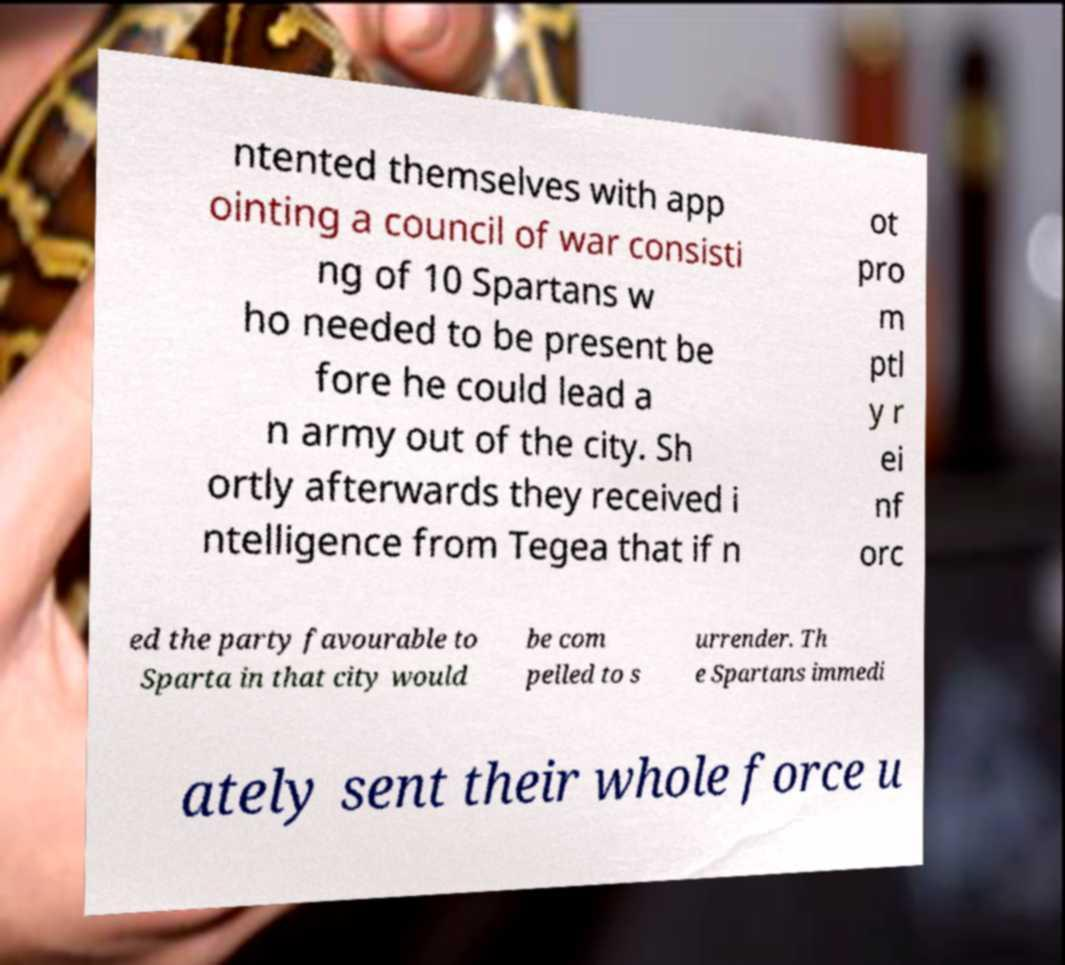For documentation purposes, I need the text within this image transcribed. Could you provide that? ntented themselves with app ointing a council of war consisti ng of 10 Spartans w ho needed to be present be fore he could lead a n army out of the city. Sh ortly afterwards they received i ntelligence from Tegea that if n ot pro m ptl y r ei nf orc ed the party favourable to Sparta in that city would be com pelled to s urrender. Th e Spartans immedi ately sent their whole force u 